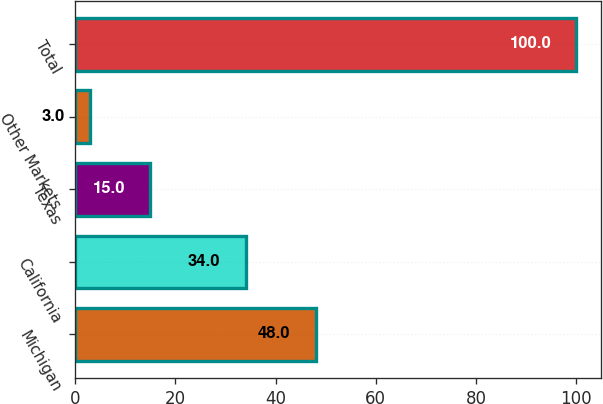Convert chart to OTSL. <chart><loc_0><loc_0><loc_500><loc_500><bar_chart><fcel>Michigan<fcel>California<fcel>Texas<fcel>Other Markets<fcel>Total<nl><fcel>48<fcel>34<fcel>15<fcel>3<fcel>100<nl></chart> 